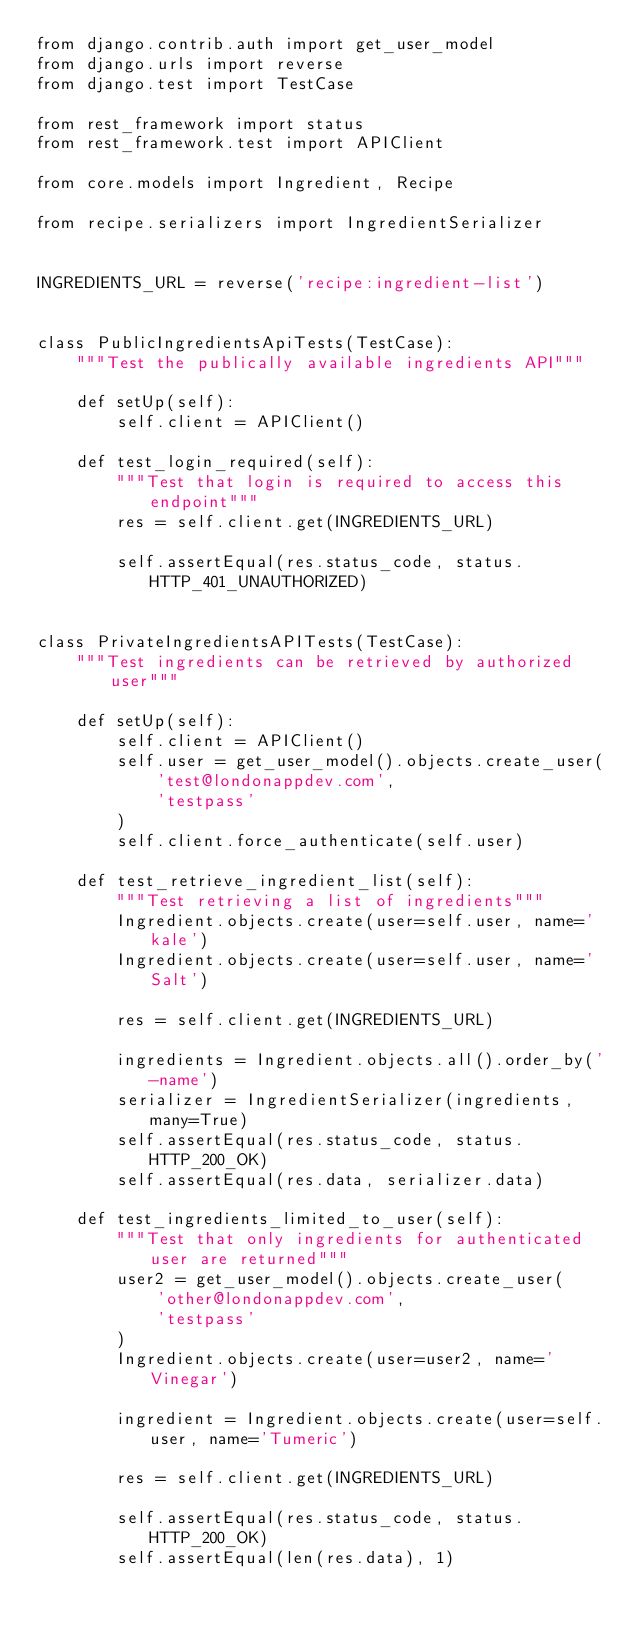Convert code to text. <code><loc_0><loc_0><loc_500><loc_500><_Python_>from django.contrib.auth import get_user_model
from django.urls import reverse
from django.test import TestCase

from rest_framework import status
from rest_framework.test import APIClient

from core.models import Ingredient, Recipe

from recipe.serializers import IngredientSerializer


INGREDIENTS_URL = reverse('recipe:ingredient-list')


class PublicIngredientsApiTests(TestCase):
    """Test the publically available ingredients API"""

    def setUp(self):
        self.client = APIClient()

    def test_login_required(self):
        """Test that login is required to access this endpoint"""
        res = self.client.get(INGREDIENTS_URL)

        self.assertEqual(res.status_code, status.HTTP_401_UNAUTHORIZED)


class PrivateIngredientsAPITests(TestCase):
    """Test ingredients can be retrieved by authorized user"""

    def setUp(self):
        self.client = APIClient()
        self.user = get_user_model().objects.create_user(
            'test@londonappdev.com',
            'testpass'
        )
        self.client.force_authenticate(self.user)

    def test_retrieve_ingredient_list(self):
        """Test retrieving a list of ingredients"""
        Ingredient.objects.create(user=self.user, name='kale')
        Ingredient.objects.create(user=self.user, name='Salt')

        res = self.client.get(INGREDIENTS_URL)

        ingredients = Ingredient.objects.all().order_by('-name')
        serializer = IngredientSerializer(ingredients, many=True)
        self.assertEqual(res.status_code, status.HTTP_200_OK)
        self.assertEqual(res.data, serializer.data)

    def test_ingredients_limited_to_user(self):
        """Test that only ingredients for authenticated user are returned"""
        user2 = get_user_model().objects.create_user(
            'other@londonappdev.com',
            'testpass'
        )
        Ingredient.objects.create(user=user2, name='Vinegar')

        ingredient = Ingredient.objects.create(user=self.user, name='Tumeric')

        res = self.client.get(INGREDIENTS_URL)

        self.assertEqual(res.status_code, status.HTTP_200_OK)
        self.assertEqual(len(res.data), 1)</code> 